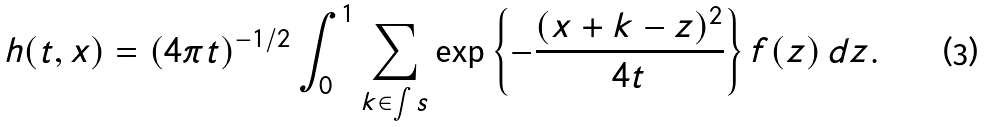Convert formula to latex. <formula><loc_0><loc_0><loc_500><loc_500>h ( t , x ) = ( 4 \pi t ) ^ { - 1 / 2 } \int _ { 0 } ^ { 1 } \sum _ { k \in \int s } \exp \left \{ - \frac { ( x + k - z ) ^ { 2 } } { 4 t } \right \} f ( z ) \, d z .</formula> 